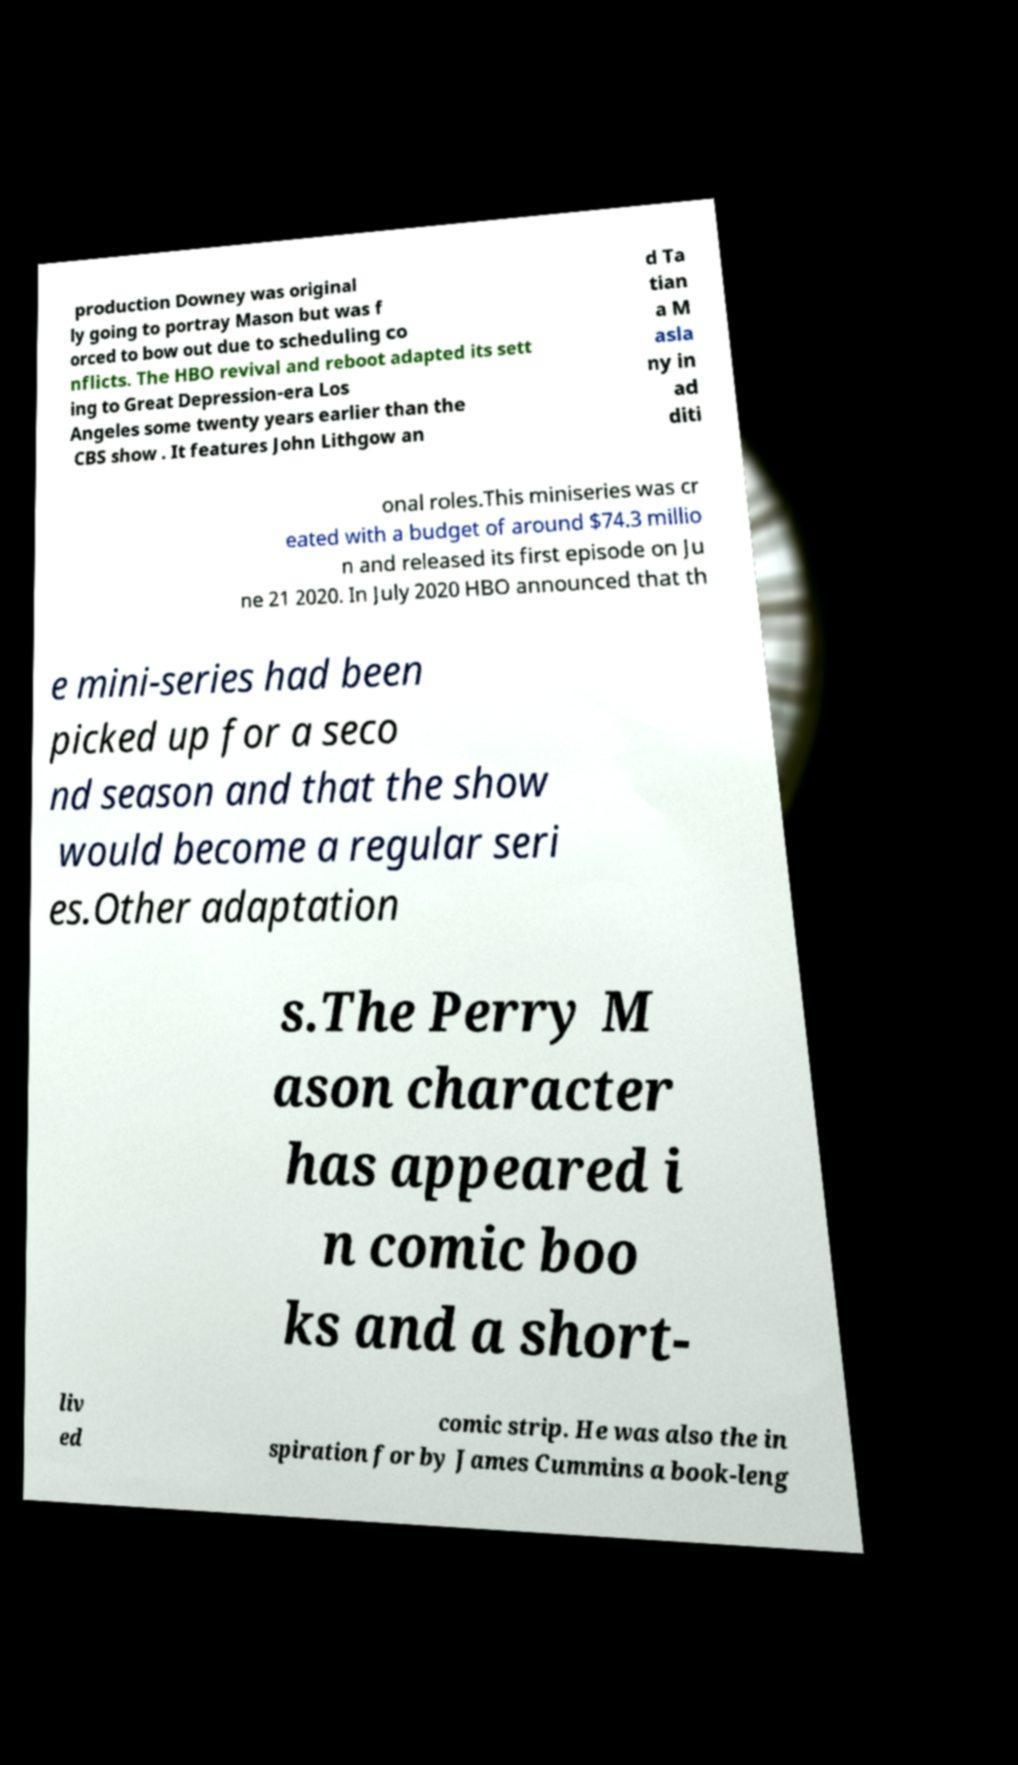What messages or text are displayed in this image? I need them in a readable, typed format. production Downey was original ly going to portray Mason but was f orced to bow out due to scheduling co nflicts. The HBO revival and reboot adapted its sett ing to Great Depression-era Los Angeles some twenty years earlier than the CBS show . It features John Lithgow an d Ta tian a M asla ny in ad diti onal roles.This miniseries was cr eated with a budget of around $74.3 millio n and released its first episode on Ju ne 21 2020. In July 2020 HBO announced that th e mini-series had been picked up for a seco nd season and that the show would become a regular seri es.Other adaptation s.The Perry M ason character has appeared i n comic boo ks and a short- liv ed comic strip. He was also the in spiration for by James Cummins a book-leng 